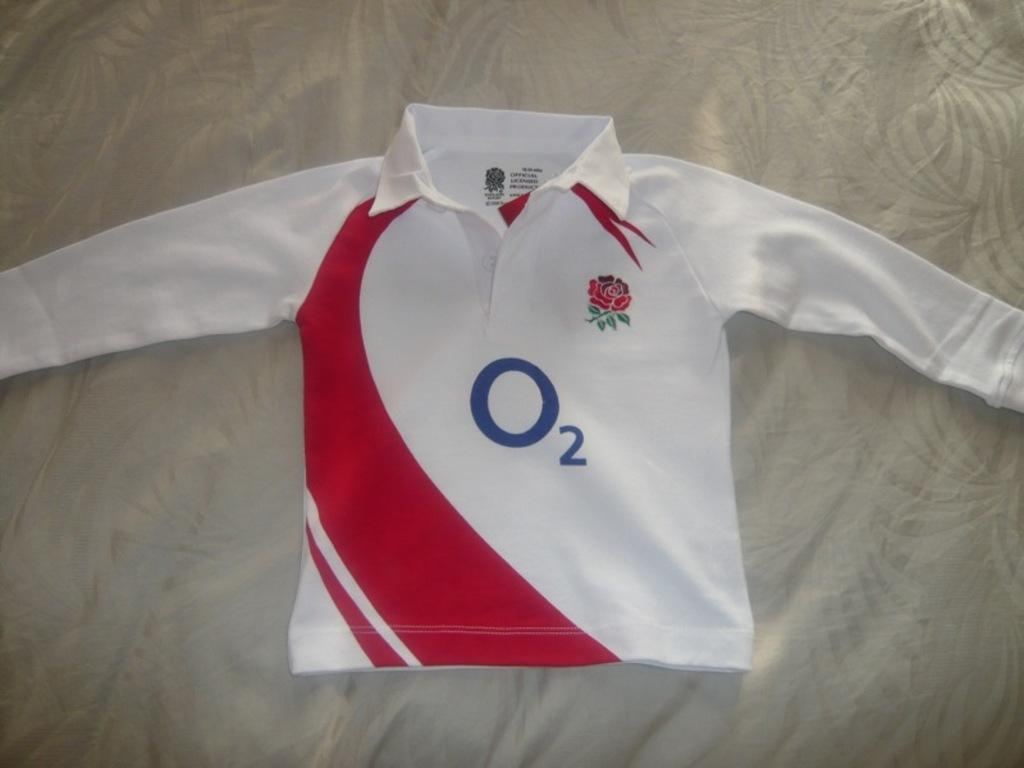<image>
Create a compact narrative representing the image presented. a jersey that has the letter o on it 